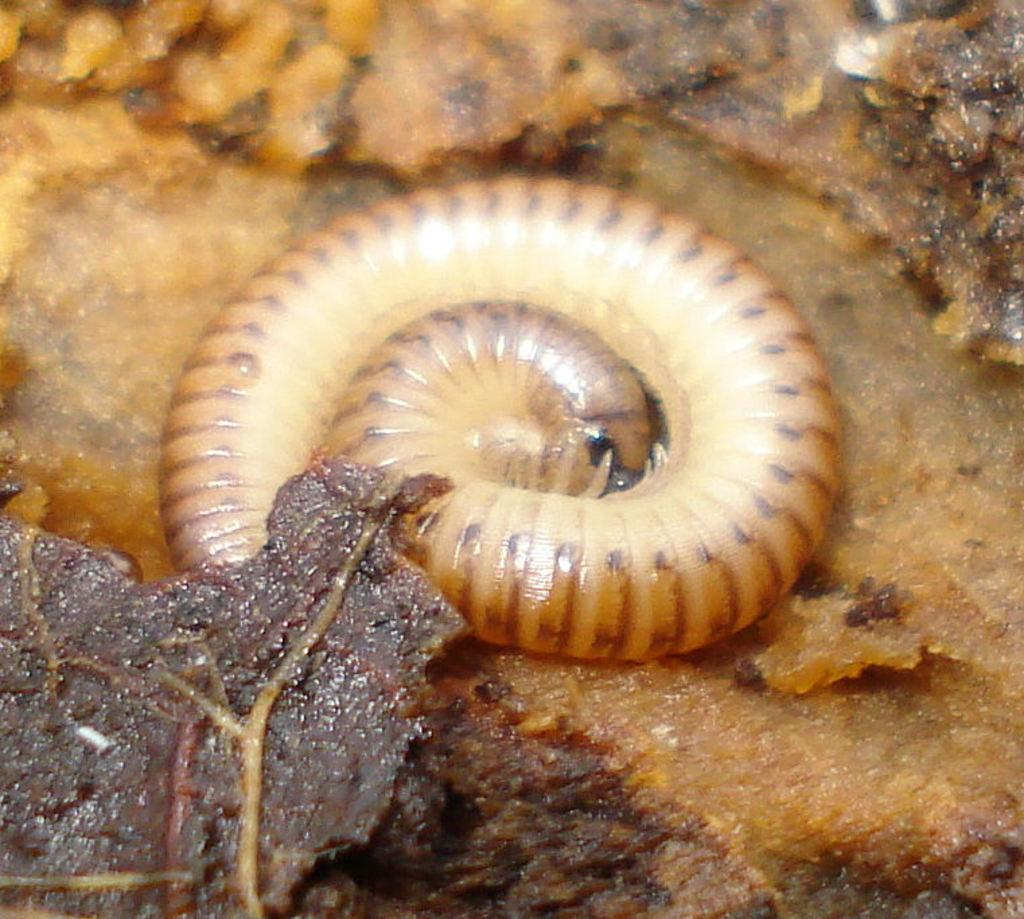What type of creature can be seen in the image? There is an insect in the image. Where is the insect located in the image? The insect is on a surface. What type of event is the daughter attending in the image? There is no daughter or event present in the image; it only features an insect on a surface. How many frogs can be seen in the image? There are no frogs present in the image; it only features an insect on a surface. 